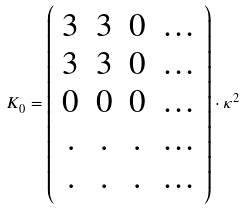Convert formula to latex. <formula><loc_0><loc_0><loc_500><loc_500>K _ { 0 } = \left ( \begin{array} { c c c c } 3 & 3 & 0 & \dots \\ 3 & 3 & 0 & \dots \\ 0 & 0 & 0 & \dots \\ . & . & . & \dots \\ . & . & . & \dots \end{array} \right ) \cdot \kappa ^ { 2 }</formula> 